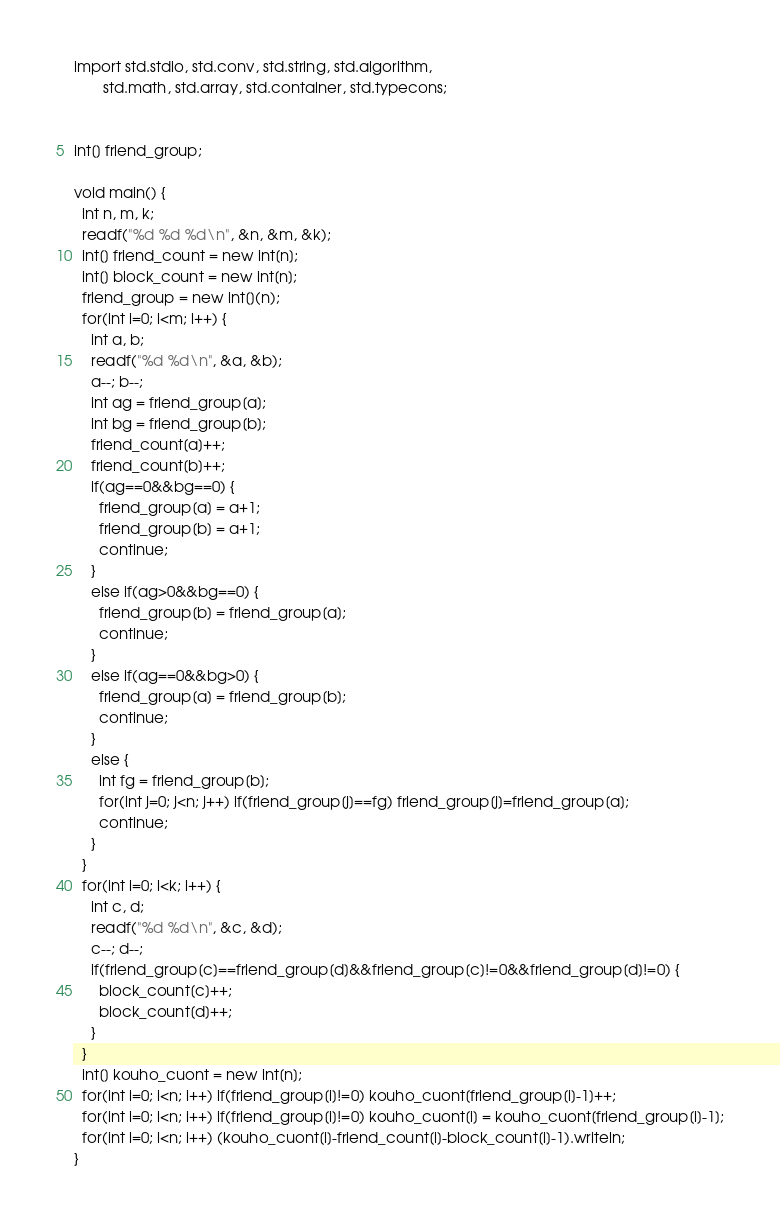<code> <loc_0><loc_0><loc_500><loc_500><_D_>import std.stdio, std.conv, std.string, std.algorithm,
       std.math, std.array, std.container, std.typecons;


int[] friend_group;

void main() {
  int n, m, k;
  readf("%d %d %d\n", &n, &m, &k);
  int[] friend_count = new int[n];
  int[] block_count = new int[n];
  friend_group = new int[](n);
  for(int i=0; i<m; i++) {
    int a, b;
    readf("%d %d\n", &a, &b);
    a--; b--;
    int ag = friend_group[a];
    int bg = friend_group[b];
    friend_count[a]++;
    friend_count[b]++;
    if(ag==0&&bg==0) {
      friend_group[a] = a+1;
      friend_group[b] = a+1;
      continue;
    }
    else if(ag>0&&bg==0) {
      friend_group[b] = friend_group[a];
      continue;
    }
    else if(ag==0&&bg>0) {
      friend_group[a] = friend_group[b];
      continue;
    }
    else {
      int fg = friend_group[b];
      for(int j=0; j<n; j++) if(friend_group[j]==fg) friend_group[j]=friend_group[a];
      continue;
    }
  }
  for(int i=0; i<k; i++) {
    int c, d;
    readf("%d %d\n", &c, &d);
    c--; d--;
    if(friend_group[c]==friend_group[d]&&friend_group[c]!=0&&friend_group[d]!=0) {
      block_count[c]++;
      block_count[d]++;
    }
  }
  int[] kouho_cuont = new int[n];
  for(int i=0; i<n; i++) if(friend_group[i]!=0) kouho_cuont[friend_group[i]-1]++;
  for(int i=0; i<n; i++) if(friend_group[i]!=0) kouho_cuont[i] = kouho_cuont[friend_group[i]-1];
  for(int i=0; i<n; i++) (kouho_cuont[i]-friend_count[i]-block_count[i]-1).writeln;
}

</code> 